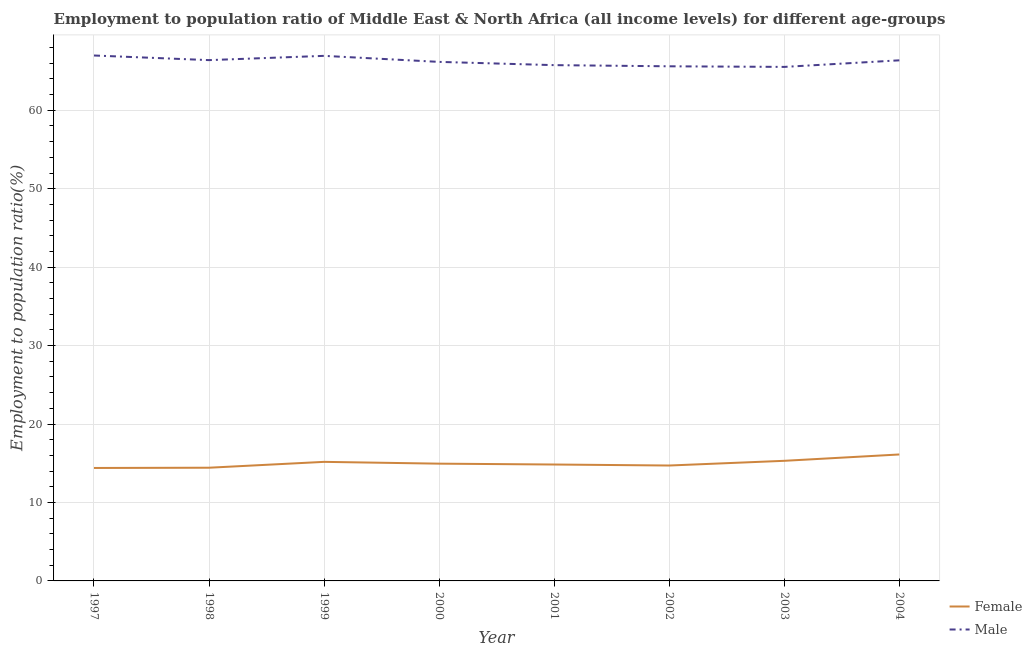Does the line corresponding to employment to population ratio(male) intersect with the line corresponding to employment to population ratio(female)?
Provide a succinct answer. No. Is the number of lines equal to the number of legend labels?
Offer a very short reply. Yes. What is the employment to population ratio(female) in 2002?
Give a very brief answer. 14.71. Across all years, what is the maximum employment to population ratio(female)?
Make the answer very short. 16.12. Across all years, what is the minimum employment to population ratio(male)?
Provide a short and direct response. 65.53. In which year was the employment to population ratio(female) minimum?
Offer a very short reply. 1997. What is the total employment to population ratio(female) in the graph?
Your answer should be compact. 119.94. What is the difference between the employment to population ratio(male) in 2001 and that in 2003?
Ensure brevity in your answer.  0.22. What is the difference between the employment to population ratio(male) in 2001 and the employment to population ratio(female) in 2000?
Provide a short and direct response. 50.8. What is the average employment to population ratio(female) per year?
Your answer should be very brief. 14.99. In the year 2002, what is the difference between the employment to population ratio(female) and employment to population ratio(male)?
Ensure brevity in your answer.  -50.89. What is the ratio of the employment to population ratio(male) in 1997 to that in 2001?
Your answer should be compact. 1.02. Is the employment to population ratio(male) in 2000 less than that in 2004?
Provide a short and direct response. Yes. Is the difference between the employment to population ratio(male) in 2000 and 2002 greater than the difference between the employment to population ratio(female) in 2000 and 2002?
Provide a succinct answer. Yes. What is the difference between the highest and the second highest employment to population ratio(female)?
Give a very brief answer. 0.81. What is the difference between the highest and the lowest employment to population ratio(male)?
Offer a very short reply. 1.45. In how many years, is the employment to population ratio(male) greater than the average employment to population ratio(male) taken over all years?
Provide a short and direct response. 4. Is the sum of the employment to population ratio(male) in 2002 and 2004 greater than the maximum employment to population ratio(female) across all years?
Offer a terse response. Yes. Are the values on the major ticks of Y-axis written in scientific E-notation?
Provide a short and direct response. No. Does the graph contain any zero values?
Make the answer very short. No. Where does the legend appear in the graph?
Provide a succinct answer. Bottom right. How many legend labels are there?
Your response must be concise. 2. How are the legend labels stacked?
Ensure brevity in your answer.  Vertical. What is the title of the graph?
Your answer should be very brief. Employment to population ratio of Middle East & North Africa (all income levels) for different age-groups. What is the label or title of the X-axis?
Offer a very short reply. Year. What is the Employment to population ratio(%) of Female in 1997?
Give a very brief answer. 14.4. What is the Employment to population ratio(%) of Male in 1997?
Give a very brief answer. 66.98. What is the Employment to population ratio(%) of Female in 1998?
Provide a succinct answer. 14.43. What is the Employment to population ratio(%) in Male in 1998?
Your response must be concise. 66.39. What is the Employment to population ratio(%) in Female in 1999?
Give a very brief answer. 15.18. What is the Employment to population ratio(%) of Male in 1999?
Offer a terse response. 66.94. What is the Employment to population ratio(%) in Female in 2000?
Your answer should be compact. 14.95. What is the Employment to population ratio(%) in Male in 2000?
Give a very brief answer. 66.17. What is the Employment to population ratio(%) of Female in 2001?
Your answer should be compact. 14.84. What is the Employment to population ratio(%) in Male in 2001?
Give a very brief answer. 65.75. What is the Employment to population ratio(%) of Female in 2002?
Your answer should be very brief. 14.71. What is the Employment to population ratio(%) in Male in 2002?
Your answer should be compact. 65.6. What is the Employment to population ratio(%) of Female in 2003?
Keep it short and to the point. 15.31. What is the Employment to population ratio(%) of Male in 2003?
Offer a terse response. 65.53. What is the Employment to population ratio(%) of Female in 2004?
Offer a terse response. 16.12. What is the Employment to population ratio(%) of Male in 2004?
Your response must be concise. 66.37. Across all years, what is the maximum Employment to population ratio(%) in Female?
Provide a succinct answer. 16.12. Across all years, what is the maximum Employment to population ratio(%) in Male?
Offer a terse response. 66.98. Across all years, what is the minimum Employment to population ratio(%) in Female?
Provide a short and direct response. 14.4. Across all years, what is the minimum Employment to population ratio(%) of Male?
Your answer should be very brief. 65.53. What is the total Employment to population ratio(%) of Female in the graph?
Your answer should be very brief. 119.94. What is the total Employment to population ratio(%) in Male in the graph?
Keep it short and to the point. 529.73. What is the difference between the Employment to population ratio(%) of Female in 1997 and that in 1998?
Give a very brief answer. -0.03. What is the difference between the Employment to population ratio(%) in Male in 1997 and that in 1998?
Keep it short and to the point. 0.59. What is the difference between the Employment to population ratio(%) of Female in 1997 and that in 1999?
Ensure brevity in your answer.  -0.78. What is the difference between the Employment to population ratio(%) of Male in 1997 and that in 1999?
Provide a short and direct response. 0.05. What is the difference between the Employment to population ratio(%) in Female in 1997 and that in 2000?
Keep it short and to the point. -0.55. What is the difference between the Employment to population ratio(%) in Male in 1997 and that in 2000?
Offer a terse response. 0.81. What is the difference between the Employment to population ratio(%) of Female in 1997 and that in 2001?
Offer a very short reply. -0.44. What is the difference between the Employment to population ratio(%) of Male in 1997 and that in 2001?
Provide a short and direct response. 1.23. What is the difference between the Employment to population ratio(%) in Female in 1997 and that in 2002?
Offer a very short reply. -0.31. What is the difference between the Employment to population ratio(%) of Male in 1997 and that in 2002?
Offer a terse response. 1.38. What is the difference between the Employment to population ratio(%) in Female in 1997 and that in 2003?
Give a very brief answer. -0.91. What is the difference between the Employment to population ratio(%) in Male in 1997 and that in 2003?
Your answer should be very brief. 1.45. What is the difference between the Employment to population ratio(%) of Female in 1997 and that in 2004?
Offer a very short reply. -1.72. What is the difference between the Employment to population ratio(%) of Male in 1997 and that in 2004?
Your answer should be compact. 0.61. What is the difference between the Employment to population ratio(%) in Female in 1998 and that in 1999?
Offer a very short reply. -0.75. What is the difference between the Employment to population ratio(%) in Male in 1998 and that in 1999?
Provide a succinct answer. -0.54. What is the difference between the Employment to population ratio(%) of Female in 1998 and that in 2000?
Make the answer very short. -0.52. What is the difference between the Employment to population ratio(%) in Male in 1998 and that in 2000?
Offer a very short reply. 0.22. What is the difference between the Employment to population ratio(%) of Female in 1998 and that in 2001?
Your response must be concise. -0.41. What is the difference between the Employment to population ratio(%) of Male in 1998 and that in 2001?
Ensure brevity in your answer.  0.64. What is the difference between the Employment to population ratio(%) of Female in 1998 and that in 2002?
Keep it short and to the point. -0.28. What is the difference between the Employment to population ratio(%) in Male in 1998 and that in 2002?
Your answer should be compact. 0.79. What is the difference between the Employment to population ratio(%) in Female in 1998 and that in 2003?
Keep it short and to the point. -0.88. What is the difference between the Employment to population ratio(%) in Male in 1998 and that in 2003?
Offer a very short reply. 0.86. What is the difference between the Employment to population ratio(%) in Female in 1998 and that in 2004?
Provide a short and direct response. -1.69. What is the difference between the Employment to population ratio(%) in Male in 1998 and that in 2004?
Make the answer very short. 0.03. What is the difference between the Employment to population ratio(%) of Female in 1999 and that in 2000?
Your answer should be compact. 0.23. What is the difference between the Employment to population ratio(%) in Male in 1999 and that in 2000?
Give a very brief answer. 0.77. What is the difference between the Employment to population ratio(%) of Female in 1999 and that in 2001?
Give a very brief answer. 0.34. What is the difference between the Employment to population ratio(%) of Male in 1999 and that in 2001?
Your answer should be very brief. 1.18. What is the difference between the Employment to population ratio(%) in Female in 1999 and that in 2002?
Ensure brevity in your answer.  0.47. What is the difference between the Employment to population ratio(%) in Male in 1999 and that in 2002?
Offer a very short reply. 1.33. What is the difference between the Employment to population ratio(%) in Female in 1999 and that in 2003?
Make the answer very short. -0.13. What is the difference between the Employment to population ratio(%) of Male in 1999 and that in 2003?
Your answer should be compact. 1.41. What is the difference between the Employment to population ratio(%) of Female in 1999 and that in 2004?
Offer a very short reply. -0.94. What is the difference between the Employment to population ratio(%) of Male in 1999 and that in 2004?
Make the answer very short. 0.57. What is the difference between the Employment to population ratio(%) in Female in 2000 and that in 2001?
Offer a terse response. 0.11. What is the difference between the Employment to population ratio(%) of Male in 2000 and that in 2001?
Your response must be concise. 0.41. What is the difference between the Employment to population ratio(%) of Female in 2000 and that in 2002?
Offer a very short reply. 0.24. What is the difference between the Employment to population ratio(%) in Male in 2000 and that in 2002?
Make the answer very short. 0.56. What is the difference between the Employment to population ratio(%) in Female in 2000 and that in 2003?
Your response must be concise. -0.36. What is the difference between the Employment to population ratio(%) in Male in 2000 and that in 2003?
Give a very brief answer. 0.64. What is the difference between the Employment to population ratio(%) of Female in 2000 and that in 2004?
Keep it short and to the point. -1.17. What is the difference between the Employment to population ratio(%) in Male in 2000 and that in 2004?
Provide a short and direct response. -0.2. What is the difference between the Employment to population ratio(%) in Female in 2001 and that in 2002?
Give a very brief answer. 0.13. What is the difference between the Employment to population ratio(%) in Male in 2001 and that in 2002?
Your response must be concise. 0.15. What is the difference between the Employment to population ratio(%) in Female in 2001 and that in 2003?
Offer a very short reply. -0.47. What is the difference between the Employment to population ratio(%) of Male in 2001 and that in 2003?
Your answer should be very brief. 0.22. What is the difference between the Employment to population ratio(%) of Female in 2001 and that in 2004?
Your answer should be very brief. -1.28. What is the difference between the Employment to population ratio(%) of Male in 2001 and that in 2004?
Your response must be concise. -0.61. What is the difference between the Employment to population ratio(%) of Female in 2002 and that in 2003?
Offer a very short reply. -0.6. What is the difference between the Employment to population ratio(%) in Male in 2002 and that in 2003?
Your answer should be very brief. 0.08. What is the difference between the Employment to population ratio(%) in Female in 2002 and that in 2004?
Provide a short and direct response. -1.41. What is the difference between the Employment to population ratio(%) of Male in 2002 and that in 2004?
Provide a short and direct response. -0.76. What is the difference between the Employment to population ratio(%) in Female in 2003 and that in 2004?
Offer a terse response. -0.81. What is the difference between the Employment to population ratio(%) of Male in 2003 and that in 2004?
Your answer should be very brief. -0.84. What is the difference between the Employment to population ratio(%) of Female in 1997 and the Employment to population ratio(%) of Male in 1998?
Your answer should be compact. -51.99. What is the difference between the Employment to population ratio(%) in Female in 1997 and the Employment to population ratio(%) in Male in 1999?
Make the answer very short. -52.54. What is the difference between the Employment to population ratio(%) in Female in 1997 and the Employment to population ratio(%) in Male in 2000?
Your response must be concise. -51.77. What is the difference between the Employment to population ratio(%) in Female in 1997 and the Employment to population ratio(%) in Male in 2001?
Offer a terse response. -51.35. What is the difference between the Employment to population ratio(%) in Female in 1997 and the Employment to population ratio(%) in Male in 2002?
Keep it short and to the point. -51.2. What is the difference between the Employment to population ratio(%) of Female in 1997 and the Employment to population ratio(%) of Male in 2003?
Offer a very short reply. -51.13. What is the difference between the Employment to population ratio(%) in Female in 1997 and the Employment to population ratio(%) in Male in 2004?
Give a very brief answer. -51.97. What is the difference between the Employment to population ratio(%) in Female in 1998 and the Employment to population ratio(%) in Male in 1999?
Offer a very short reply. -52.5. What is the difference between the Employment to population ratio(%) of Female in 1998 and the Employment to population ratio(%) of Male in 2000?
Ensure brevity in your answer.  -51.74. What is the difference between the Employment to population ratio(%) in Female in 1998 and the Employment to population ratio(%) in Male in 2001?
Keep it short and to the point. -51.32. What is the difference between the Employment to population ratio(%) of Female in 1998 and the Employment to population ratio(%) of Male in 2002?
Your answer should be very brief. -51.17. What is the difference between the Employment to population ratio(%) in Female in 1998 and the Employment to population ratio(%) in Male in 2003?
Your answer should be very brief. -51.1. What is the difference between the Employment to population ratio(%) of Female in 1998 and the Employment to population ratio(%) of Male in 2004?
Your response must be concise. -51.94. What is the difference between the Employment to population ratio(%) of Female in 1999 and the Employment to population ratio(%) of Male in 2000?
Provide a short and direct response. -50.99. What is the difference between the Employment to population ratio(%) of Female in 1999 and the Employment to population ratio(%) of Male in 2001?
Offer a very short reply. -50.57. What is the difference between the Employment to population ratio(%) of Female in 1999 and the Employment to population ratio(%) of Male in 2002?
Keep it short and to the point. -50.43. What is the difference between the Employment to population ratio(%) in Female in 1999 and the Employment to population ratio(%) in Male in 2003?
Provide a succinct answer. -50.35. What is the difference between the Employment to population ratio(%) of Female in 1999 and the Employment to population ratio(%) of Male in 2004?
Provide a short and direct response. -51.19. What is the difference between the Employment to population ratio(%) in Female in 2000 and the Employment to population ratio(%) in Male in 2001?
Keep it short and to the point. -50.8. What is the difference between the Employment to population ratio(%) in Female in 2000 and the Employment to population ratio(%) in Male in 2002?
Provide a short and direct response. -50.66. What is the difference between the Employment to population ratio(%) of Female in 2000 and the Employment to population ratio(%) of Male in 2003?
Offer a very short reply. -50.58. What is the difference between the Employment to population ratio(%) of Female in 2000 and the Employment to population ratio(%) of Male in 2004?
Provide a short and direct response. -51.42. What is the difference between the Employment to population ratio(%) of Female in 2001 and the Employment to population ratio(%) of Male in 2002?
Your answer should be compact. -50.77. What is the difference between the Employment to population ratio(%) of Female in 2001 and the Employment to population ratio(%) of Male in 2003?
Give a very brief answer. -50.69. What is the difference between the Employment to population ratio(%) of Female in 2001 and the Employment to population ratio(%) of Male in 2004?
Provide a succinct answer. -51.53. What is the difference between the Employment to population ratio(%) in Female in 2002 and the Employment to population ratio(%) in Male in 2003?
Give a very brief answer. -50.82. What is the difference between the Employment to population ratio(%) of Female in 2002 and the Employment to population ratio(%) of Male in 2004?
Make the answer very short. -51.65. What is the difference between the Employment to population ratio(%) of Female in 2003 and the Employment to population ratio(%) of Male in 2004?
Keep it short and to the point. -51.05. What is the average Employment to population ratio(%) in Female per year?
Ensure brevity in your answer.  14.99. What is the average Employment to population ratio(%) of Male per year?
Provide a short and direct response. 66.22. In the year 1997, what is the difference between the Employment to population ratio(%) in Female and Employment to population ratio(%) in Male?
Your response must be concise. -52.58. In the year 1998, what is the difference between the Employment to population ratio(%) of Female and Employment to population ratio(%) of Male?
Provide a succinct answer. -51.96. In the year 1999, what is the difference between the Employment to population ratio(%) of Female and Employment to population ratio(%) of Male?
Your response must be concise. -51.76. In the year 2000, what is the difference between the Employment to population ratio(%) in Female and Employment to population ratio(%) in Male?
Provide a short and direct response. -51.22. In the year 2001, what is the difference between the Employment to population ratio(%) of Female and Employment to population ratio(%) of Male?
Provide a short and direct response. -50.91. In the year 2002, what is the difference between the Employment to population ratio(%) of Female and Employment to population ratio(%) of Male?
Your answer should be very brief. -50.89. In the year 2003, what is the difference between the Employment to population ratio(%) of Female and Employment to population ratio(%) of Male?
Your answer should be very brief. -50.22. In the year 2004, what is the difference between the Employment to population ratio(%) in Female and Employment to population ratio(%) in Male?
Make the answer very short. -50.25. What is the ratio of the Employment to population ratio(%) of Male in 1997 to that in 1998?
Offer a terse response. 1.01. What is the ratio of the Employment to population ratio(%) in Female in 1997 to that in 1999?
Your answer should be compact. 0.95. What is the ratio of the Employment to population ratio(%) of Female in 1997 to that in 2000?
Provide a succinct answer. 0.96. What is the ratio of the Employment to population ratio(%) of Male in 1997 to that in 2000?
Make the answer very short. 1.01. What is the ratio of the Employment to population ratio(%) of Female in 1997 to that in 2001?
Keep it short and to the point. 0.97. What is the ratio of the Employment to population ratio(%) in Male in 1997 to that in 2001?
Offer a terse response. 1.02. What is the ratio of the Employment to population ratio(%) in Female in 1997 to that in 2002?
Provide a short and direct response. 0.98. What is the ratio of the Employment to population ratio(%) in Male in 1997 to that in 2002?
Your response must be concise. 1.02. What is the ratio of the Employment to population ratio(%) in Female in 1997 to that in 2003?
Your response must be concise. 0.94. What is the ratio of the Employment to population ratio(%) of Male in 1997 to that in 2003?
Your answer should be very brief. 1.02. What is the ratio of the Employment to population ratio(%) of Female in 1997 to that in 2004?
Your answer should be very brief. 0.89. What is the ratio of the Employment to population ratio(%) in Male in 1997 to that in 2004?
Give a very brief answer. 1.01. What is the ratio of the Employment to population ratio(%) of Female in 1998 to that in 1999?
Ensure brevity in your answer.  0.95. What is the ratio of the Employment to population ratio(%) in Female in 1998 to that in 2000?
Offer a terse response. 0.97. What is the ratio of the Employment to population ratio(%) in Female in 1998 to that in 2001?
Keep it short and to the point. 0.97. What is the ratio of the Employment to population ratio(%) of Male in 1998 to that in 2001?
Your answer should be compact. 1.01. What is the ratio of the Employment to population ratio(%) in Female in 1998 to that in 2002?
Provide a short and direct response. 0.98. What is the ratio of the Employment to population ratio(%) of Female in 1998 to that in 2003?
Provide a succinct answer. 0.94. What is the ratio of the Employment to population ratio(%) of Male in 1998 to that in 2003?
Your response must be concise. 1.01. What is the ratio of the Employment to population ratio(%) in Female in 1998 to that in 2004?
Offer a very short reply. 0.9. What is the ratio of the Employment to population ratio(%) of Female in 1999 to that in 2000?
Your response must be concise. 1.02. What is the ratio of the Employment to population ratio(%) in Male in 1999 to that in 2000?
Your answer should be compact. 1.01. What is the ratio of the Employment to population ratio(%) of Female in 1999 to that in 2001?
Offer a terse response. 1.02. What is the ratio of the Employment to population ratio(%) of Male in 1999 to that in 2001?
Give a very brief answer. 1.02. What is the ratio of the Employment to population ratio(%) of Female in 1999 to that in 2002?
Give a very brief answer. 1.03. What is the ratio of the Employment to population ratio(%) of Male in 1999 to that in 2002?
Offer a very short reply. 1.02. What is the ratio of the Employment to population ratio(%) in Male in 1999 to that in 2003?
Your answer should be compact. 1.02. What is the ratio of the Employment to population ratio(%) in Female in 1999 to that in 2004?
Your answer should be very brief. 0.94. What is the ratio of the Employment to population ratio(%) in Male in 1999 to that in 2004?
Provide a succinct answer. 1.01. What is the ratio of the Employment to population ratio(%) in Female in 2000 to that in 2001?
Your response must be concise. 1.01. What is the ratio of the Employment to population ratio(%) of Male in 2000 to that in 2001?
Provide a succinct answer. 1.01. What is the ratio of the Employment to population ratio(%) in Female in 2000 to that in 2002?
Give a very brief answer. 1.02. What is the ratio of the Employment to population ratio(%) of Male in 2000 to that in 2002?
Your response must be concise. 1.01. What is the ratio of the Employment to population ratio(%) of Female in 2000 to that in 2003?
Offer a very short reply. 0.98. What is the ratio of the Employment to population ratio(%) of Male in 2000 to that in 2003?
Ensure brevity in your answer.  1.01. What is the ratio of the Employment to population ratio(%) in Female in 2000 to that in 2004?
Offer a very short reply. 0.93. What is the ratio of the Employment to population ratio(%) in Male in 2000 to that in 2004?
Offer a terse response. 1. What is the ratio of the Employment to population ratio(%) in Female in 2001 to that in 2002?
Provide a short and direct response. 1.01. What is the ratio of the Employment to population ratio(%) of Female in 2001 to that in 2003?
Make the answer very short. 0.97. What is the ratio of the Employment to population ratio(%) of Female in 2001 to that in 2004?
Make the answer very short. 0.92. What is the ratio of the Employment to population ratio(%) in Female in 2002 to that in 2003?
Provide a succinct answer. 0.96. What is the ratio of the Employment to population ratio(%) of Female in 2002 to that in 2004?
Keep it short and to the point. 0.91. What is the ratio of the Employment to population ratio(%) in Male in 2002 to that in 2004?
Your answer should be compact. 0.99. What is the ratio of the Employment to population ratio(%) in Female in 2003 to that in 2004?
Give a very brief answer. 0.95. What is the ratio of the Employment to population ratio(%) in Male in 2003 to that in 2004?
Offer a very short reply. 0.99. What is the difference between the highest and the second highest Employment to population ratio(%) in Female?
Offer a terse response. 0.81. What is the difference between the highest and the second highest Employment to population ratio(%) in Male?
Your answer should be very brief. 0.05. What is the difference between the highest and the lowest Employment to population ratio(%) in Female?
Give a very brief answer. 1.72. What is the difference between the highest and the lowest Employment to population ratio(%) in Male?
Your response must be concise. 1.45. 